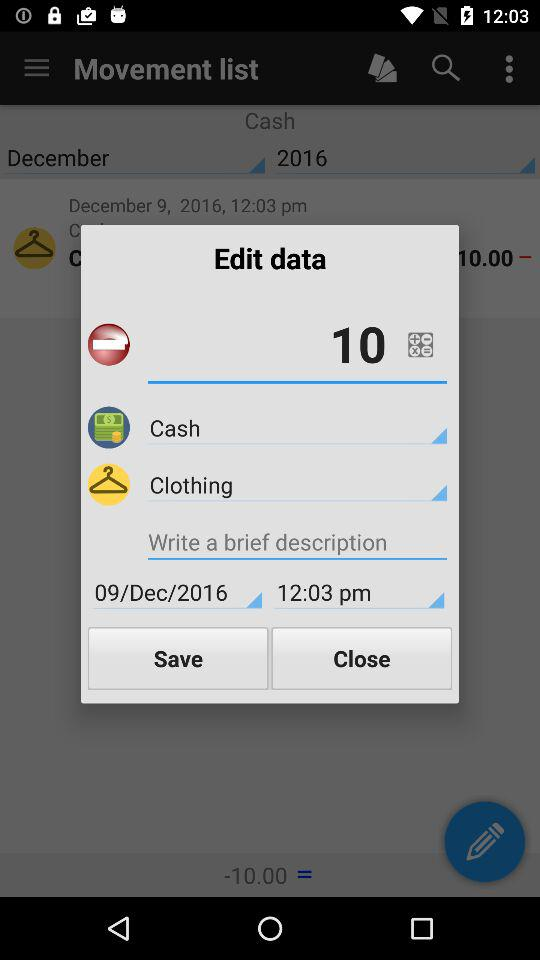What is the date? The date is December 9, 2016. 